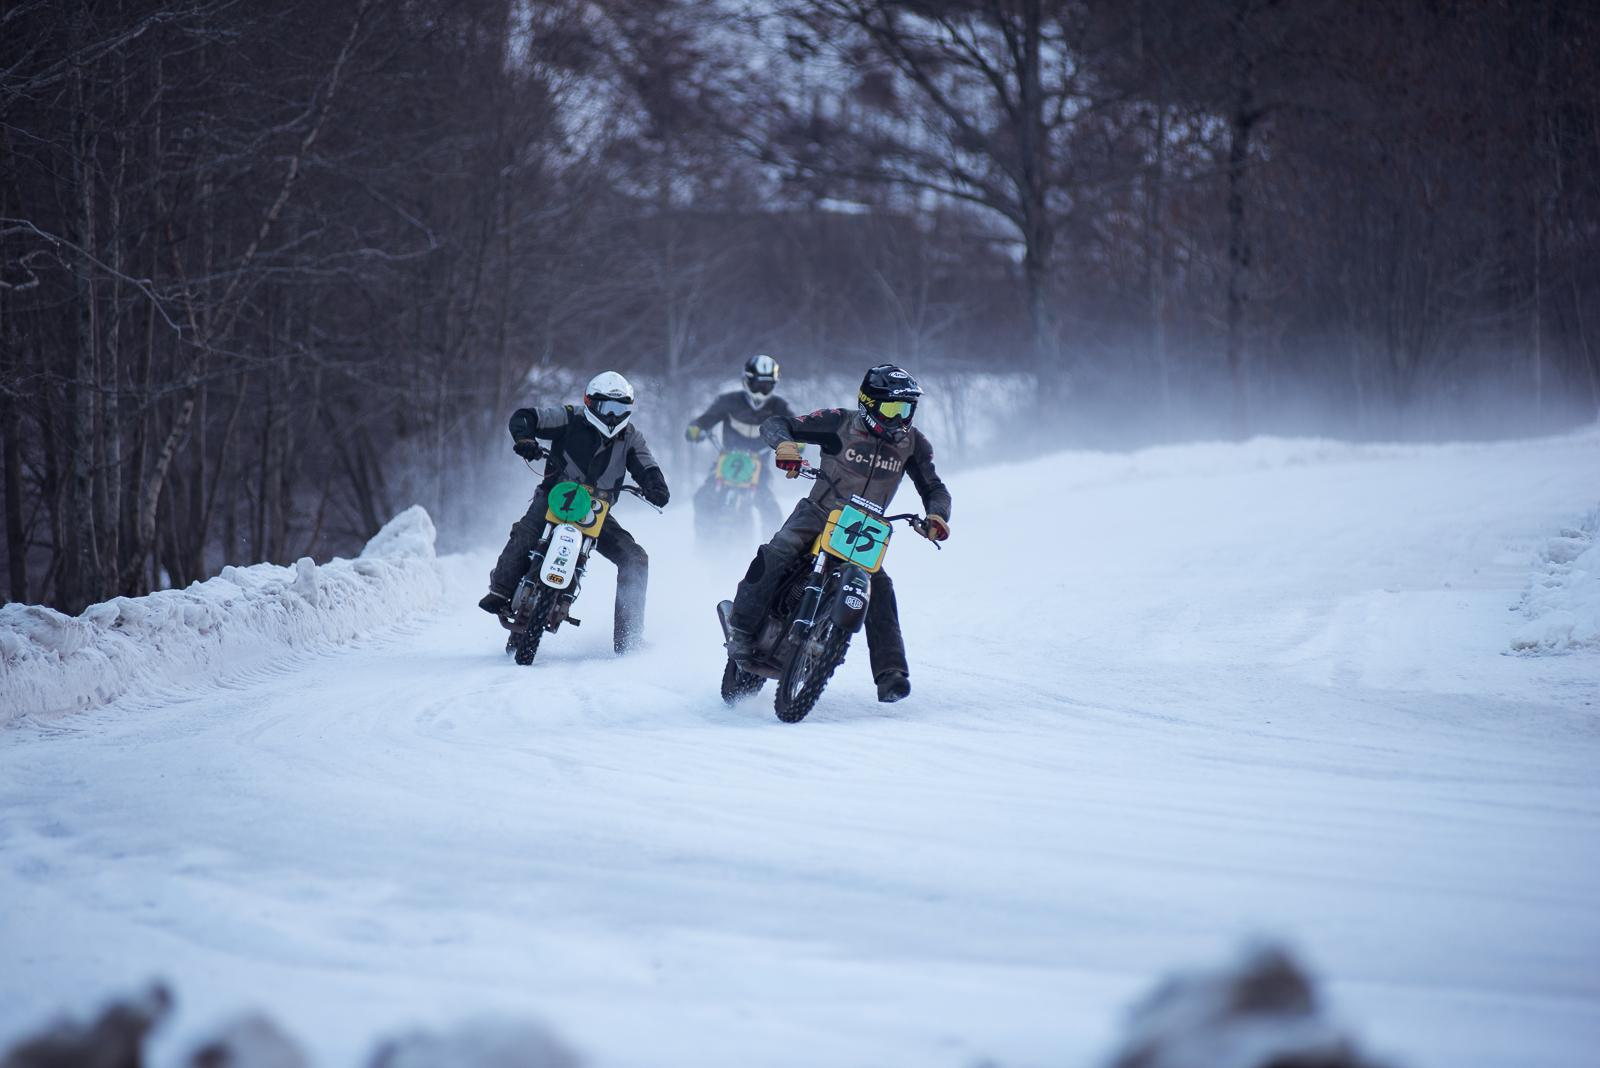How many motorbikes are there in the image? 2 